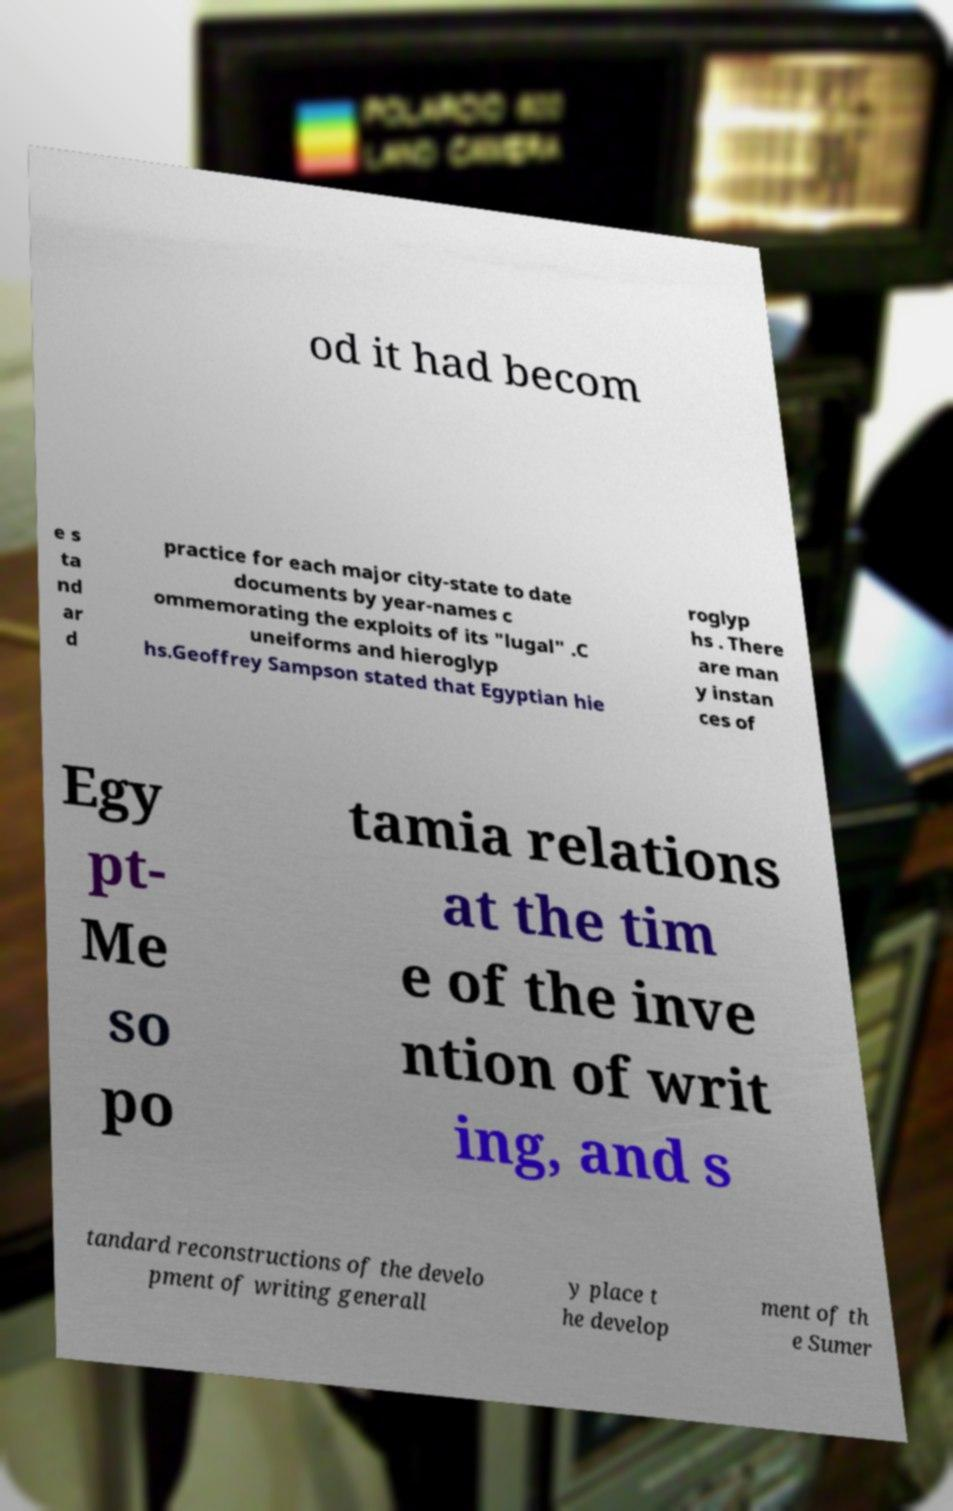Could you extract and type out the text from this image? od it had becom e s ta nd ar d practice for each major city-state to date documents by year-names c ommemorating the exploits of its "lugal" .C uneiforms and hieroglyp hs.Geoffrey Sampson stated that Egyptian hie roglyp hs . There are man y instan ces of Egy pt- Me so po tamia relations at the tim e of the inve ntion of writ ing, and s tandard reconstructions of the develo pment of writing generall y place t he develop ment of th e Sumer 